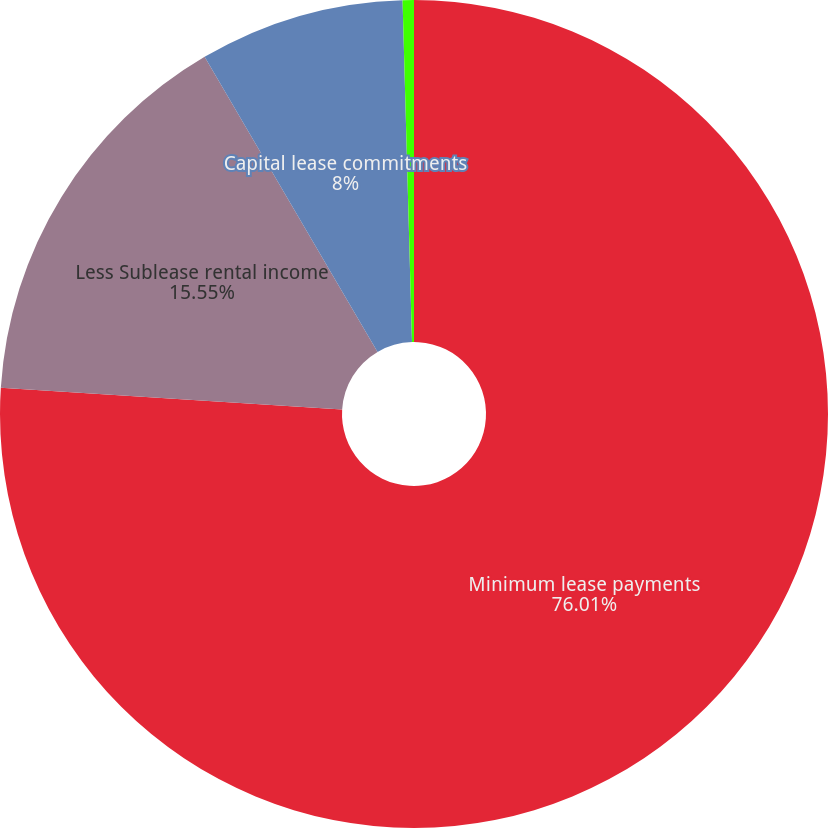Convert chart to OTSL. <chart><loc_0><loc_0><loc_500><loc_500><pie_chart><fcel>Minimum lease payments<fcel>Less Sublease rental income<fcel>Capital lease commitments<fcel>Less Interest payments<nl><fcel>76.01%<fcel>15.55%<fcel>8.0%<fcel>0.44%<nl></chart> 